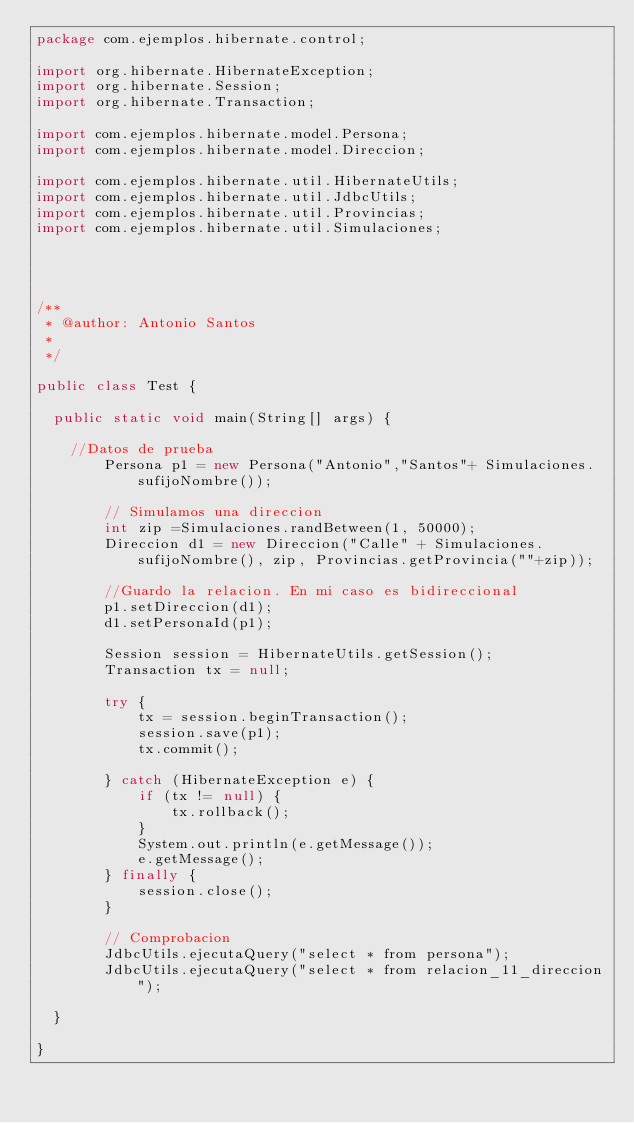<code> <loc_0><loc_0><loc_500><loc_500><_Java_>package com.ejemplos.hibernate.control;

import org.hibernate.HibernateException;
import org.hibernate.Session;
import org.hibernate.Transaction;

import com.ejemplos.hibernate.model.Persona;
import com.ejemplos.hibernate.model.Direccion;

import com.ejemplos.hibernate.util.HibernateUtils;
import com.ejemplos.hibernate.util.JdbcUtils;
import com.ejemplos.hibernate.util.Provincias;
import com.ejemplos.hibernate.util.Simulaciones;




/**
 * @author: Antonio Santos
 *
 */

public class Test {

	public static void main(String[] args) {
		
		//Datos de prueba
        Persona p1 = new Persona("Antonio","Santos"+ Simulaciones.sufijoNombre());
        
        // Simulamos una direccion
        int zip =Simulaciones.randBetween(1, 50000);
        Direccion d1 = new Direccion("Calle" + Simulaciones.sufijoNombre(), zip, Provincias.getProvincia(""+zip));
        
        //Guardo la relacion. En mi caso es bidireccional
        p1.setDireccion(d1);
        d1.setPersonaId(p1);
		
        Session session = HibernateUtils.getSession();
        Transaction tx = null;
        
        try {
            tx = session.beginTransaction();
            session.save(p1);
            tx.commit();

        } catch (HibernateException e) {
            if (tx != null) {
                tx.rollback();
            }
            System.out.println(e.getMessage());
            e.getMessage();
        } finally {
            session.close();
        }
        
        // Comprobacion
        JdbcUtils.ejecutaQuery("select * from persona");
        JdbcUtils.ejecutaQuery("select * from relacion_11_direccion");        

	}

}
</code> 